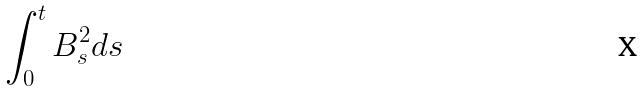<formula> <loc_0><loc_0><loc_500><loc_500>\int _ { 0 } ^ { t } B _ { s } ^ { 2 } d s</formula> 